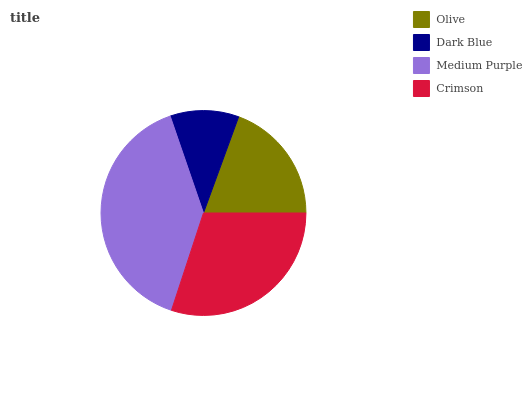Is Dark Blue the minimum?
Answer yes or no. Yes. Is Medium Purple the maximum?
Answer yes or no. Yes. Is Medium Purple the minimum?
Answer yes or no. No. Is Dark Blue the maximum?
Answer yes or no. No. Is Medium Purple greater than Dark Blue?
Answer yes or no. Yes. Is Dark Blue less than Medium Purple?
Answer yes or no. Yes. Is Dark Blue greater than Medium Purple?
Answer yes or no. No. Is Medium Purple less than Dark Blue?
Answer yes or no. No. Is Crimson the high median?
Answer yes or no. Yes. Is Olive the low median?
Answer yes or no. Yes. Is Medium Purple the high median?
Answer yes or no. No. Is Dark Blue the low median?
Answer yes or no. No. 